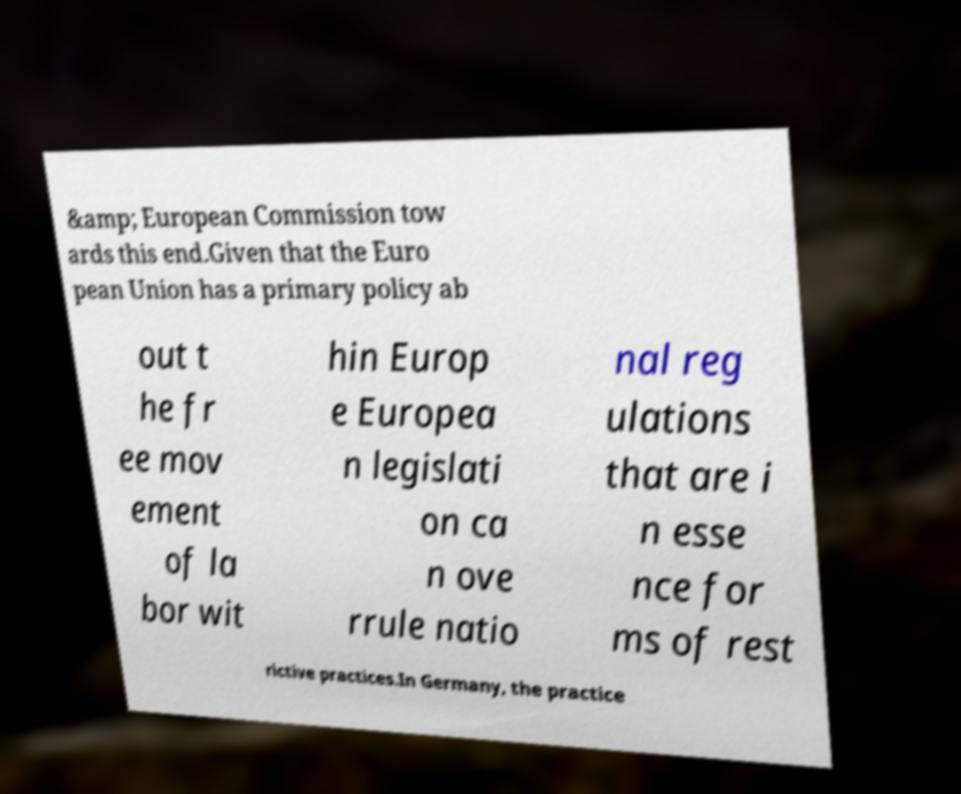Could you assist in decoding the text presented in this image and type it out clearly? &amp; European Commission tow ards this end.Given that the Euro pean Union has a primary policy ab out t he fr ee mov ement of la bor wit hin Europ e Europea n legislati on ca n ove rrule natio nal reg ulations that are i n esse nce for ms of rest rictive practices.In Germany, the practice 